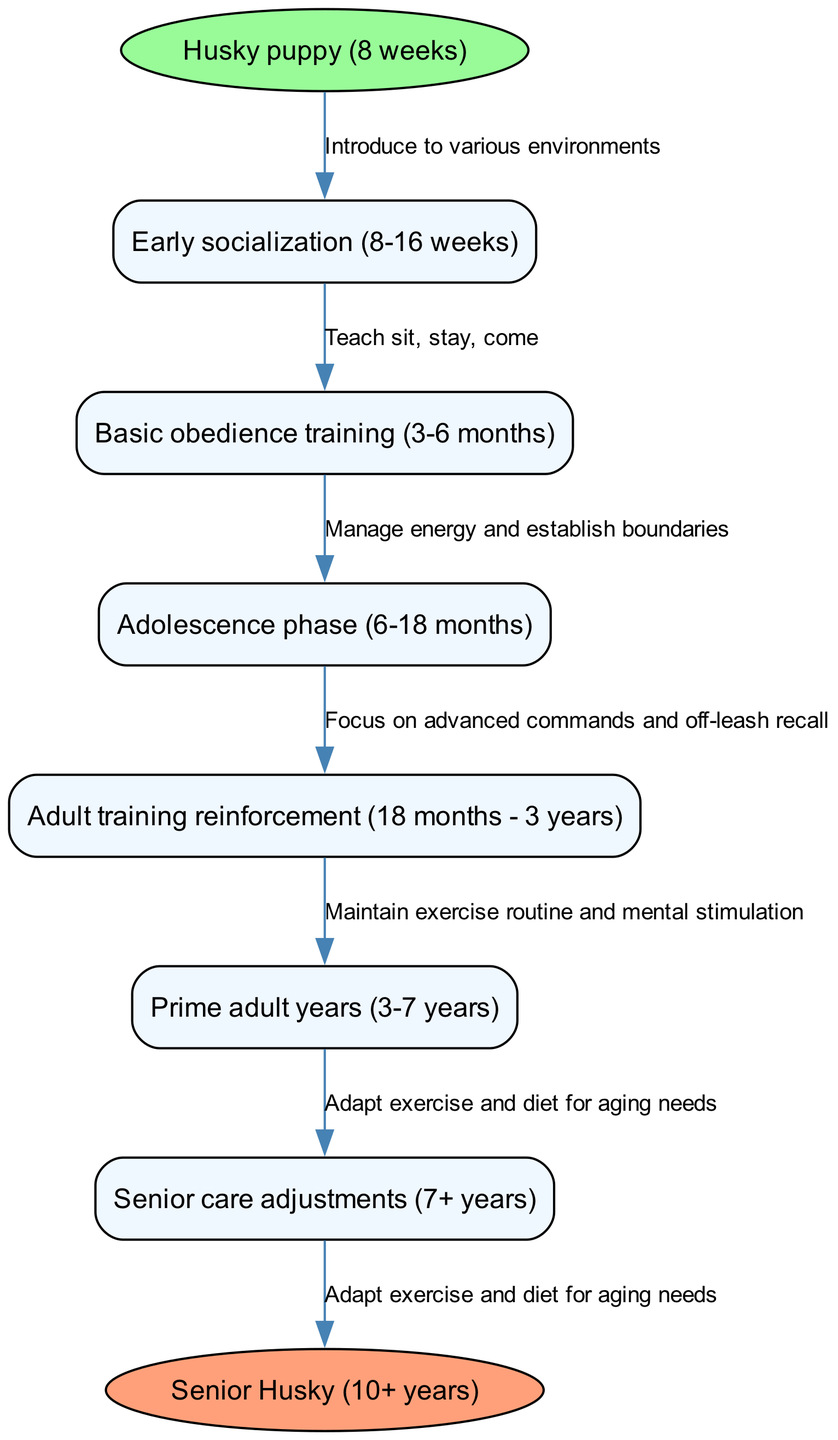What is the first training phase in the Husky lifecycle? The diagram indicates that the first training phase occurs during the timeline of the Husky puppy phase, specifically from 8 to 16 weeks, and is labeled "Early socialization."
Answer: Early socialization How many nodes are present in this diagram? The diagram presents a total of six nodes, including the start and end nodes along with the five training phases. The nodes represent key milestones in the Husky’s lifecycle.
Answer: 6 What relationship exists between the "Adult training reinforcement" and "Adolescence phase"? The diagram shows a direct edge connecting these two phases; the "Adult training reinforcement" phase follows the "Adolescence phase" indicating a continuation of training. This suggests that the learning process builds upon the previous stage.
Answer: Continuation What is the last care adjustment mentioned for the senior Husky? The final node of the diagram, which follows the training milestones, is focused on "Adapt exercise and diet for aging needs," addressing the specific requirements for senior care.
Answer: Adapt exercise and diet for aging needs What is the duration of the "Prime adult years" phase? The diagram specifies that the "Prime adult years" phase lasts from 3 to 7 years of age for the Husky. This range is established by examining the nodes that frame this phase within the overall lifecycle.
Answer: 3-7 years Which phase includes advanced commands and off-leash recall? According to the diagram, the "Adult training reinforcement" phase is where the focus shifts to advanced commands and off-leash recall training. This reinforces the training values learned in earlier stages.
Answer: Adult training reinforcement How many edges are there connecting nodes in the diagram? The diagram illustrates a total of five edges that connect the training phases and care adjustments in the Husky’s lifecycle, showing the progression through the training timeline.
Answer: 5 What key concept is emphasized during the "Adolescence phase"? The key concept emphasized during the "Adolescence phase" is the management of energy and establishment of boundaries, which reflects the behavioral challenges often faced during this stage of development.
Answer: Manage energy and establish boundaries 